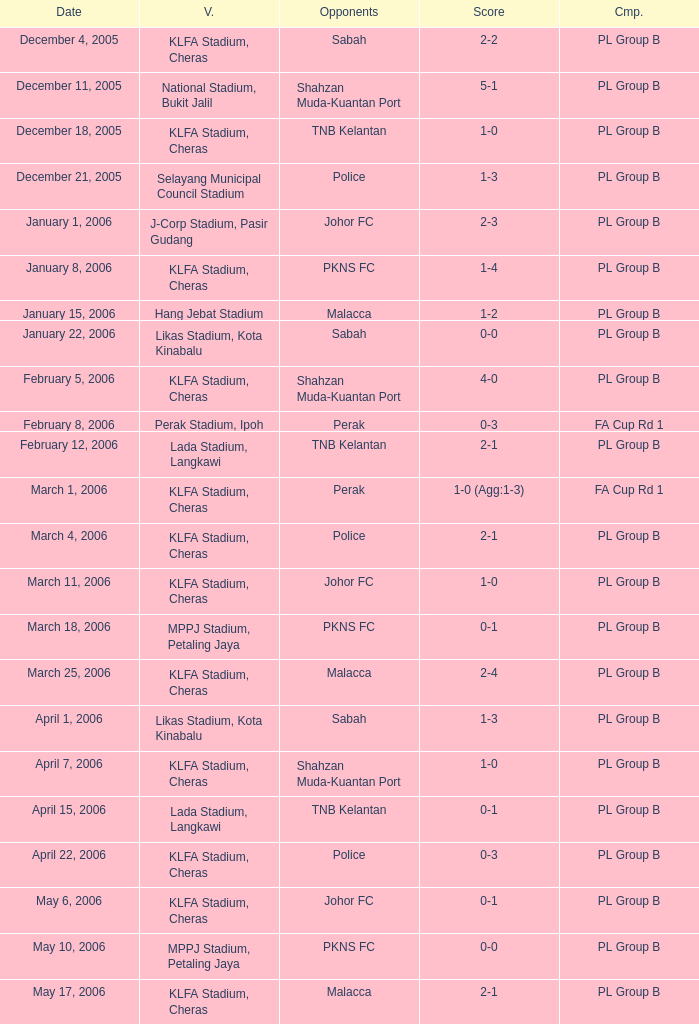Which Score has Opponents of pkns fc, and a Date of january 8, 2006? 1-4. 